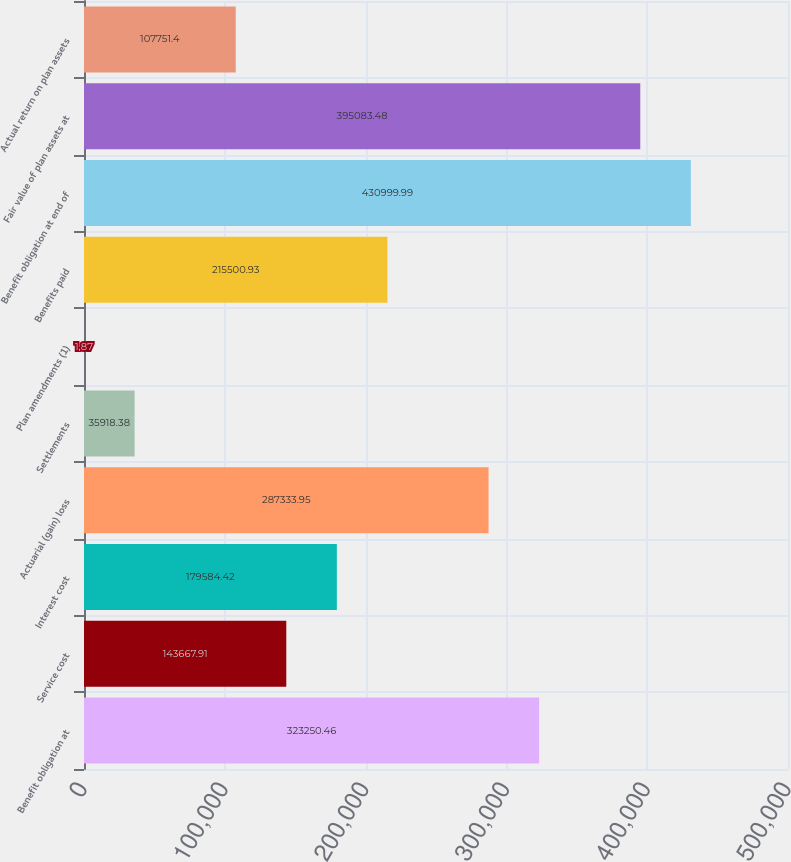<chart> <loc_0><loc_0><loc_500><loc_500><bar_chart><fcel>Benefit obligation at<fcel>Service cost<fcel>Interest cost<fcel>Actuarial (gain) loss<fcel>Settlements<fcel>Plan amendments (1)<fcel>Benefits paid<fcel>Benefit obligation at end of<fcel>Fair value of plan assets at<fcel>Actual return on plan assets<nl><fcel>323250<fcel>143668<fcel>179584<fcel>287334<fcel>35918.4<fcel>1.87<fcel>215501<fcel>431000<fcel>395083<fcel>107751<nl></chart> 